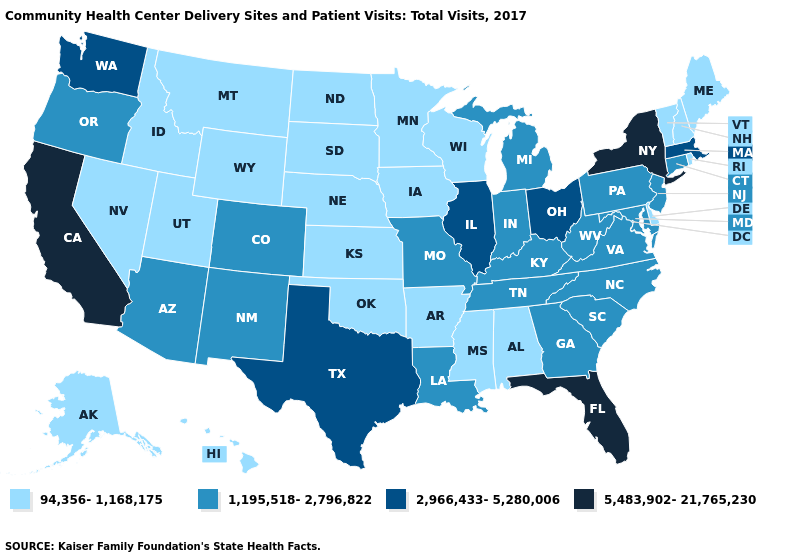How many symbols are there in the legend?
Concise answer only. 4. Name the states that have a value in the range 94,356-1,168,175?
Concise answer only. Alabama, Alaska, Arkansas, Delaware, Hawaii, Idaho, Iowa, Kansas, Maine, Minnesota, Mississippi, Montana, Nebraska, Nevada, New Hampshire, North Dakota, Oklahoma, Rhode Island, South Dakota, Utah, Vermont, Wisconsin, Wyoming. What is the highest value in the South ?
Write a very short answer. 5,483,902-21,765,230. Does Rhode Island have the lowest value in the USA?
Write a very short answer. Yes. How many symbols are there in the legend?
Write a very short answer. 4. What is the value of New Jersey?
Keep it brief. 1,195,518-2,796,822. Which states hav the highest value in the South?
Answer briefly. Florida. Among the states that border California , does Nevada have the highest value?
Short answer required. No. What is the value of California?
Answer briefly. 5,483,902-21,765,230. Does California have the highest value in the West?
Answer briefly. Yes. Which states have the lowest value in the West?
Keep it brief. Alaska, Hawaii, Idaho, Montana, Nevada, Utah, Wyoming. Does Michigan have the highest value in the USA?
Short answer required. No. Which states have the highest value in the USA?
Write a very short answer. California, Florida, New York. Among the states that border Oregon , which have the highest value?
Keep it brief. California. What is the highest value in states that border Delaware?
Answer briefly. 1,195,518-2,796,822. 